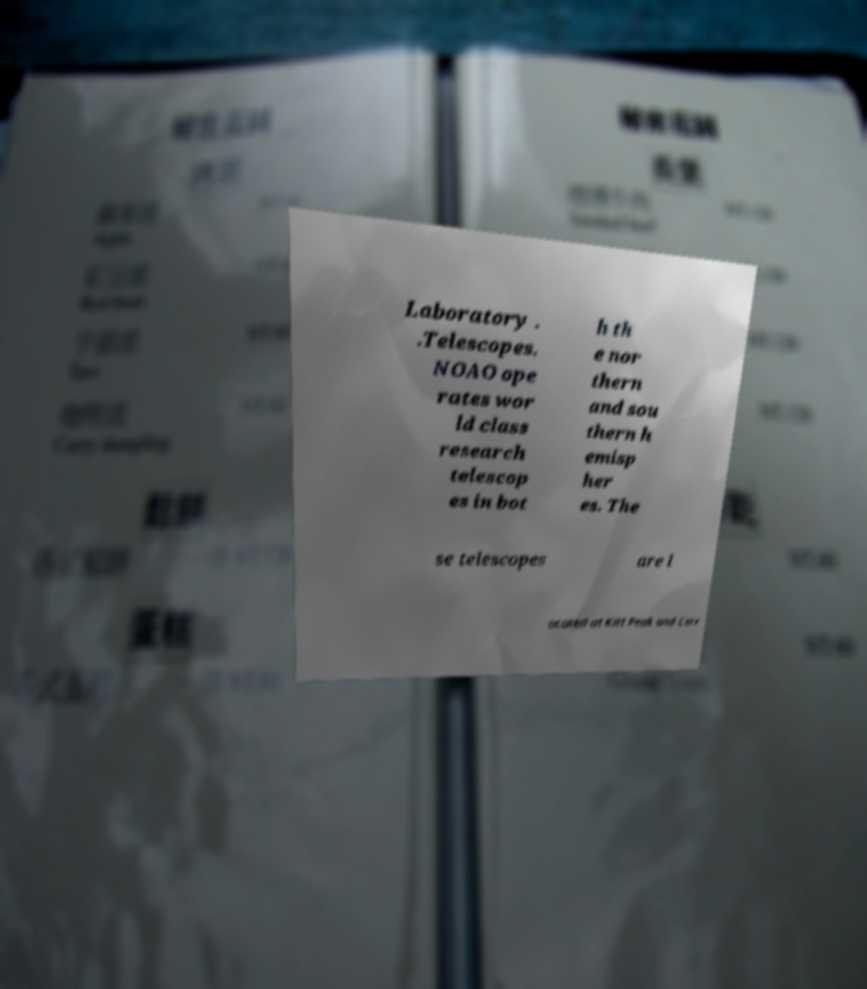There's text embedded in this image that I need extracted. Can you transcribe it verbatim? Laboratory . .Telescopes. NOAO ope rates wor ld class research telescop es in bot h th e nor thern and sou thern h emisp her es. The se telescopes are l ocated at Kitt Peak and Cerr 